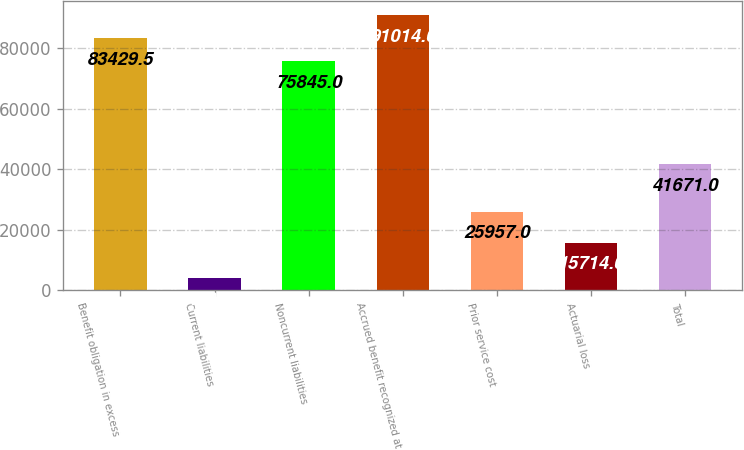Convert chart. <chart><loc_0><loc_0><loc_500><loc_500><bar_chart><fcel>Benefit obligation in excess<fcel>Current liabilities<fcel>Noncurrent liabilities<fcel>Accrued benefit recognized at<fcel>Prior service cost<fcel>Actuarial loss<fcel>Total<nl><fcel>83429.5<fcel>4107<fcel>75845<fcel>91014<fcel>25957<fcel>15714<fcel>41671<nl></chart> 